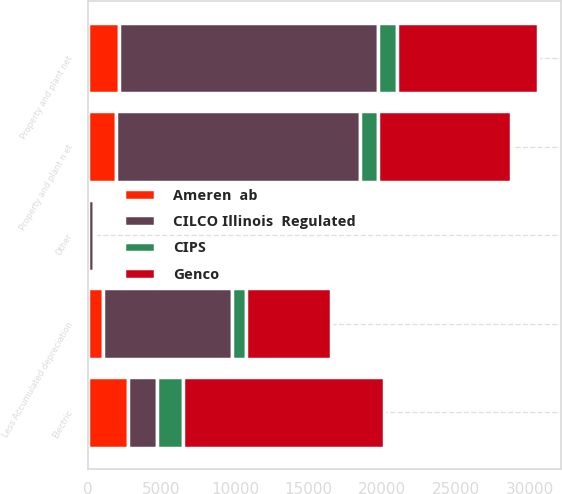<chart> <loc_0><loc_0><loc_500><loc_500><stacked_bar_chart><ecel><fcel>Electric<fcel>Other<fcel>Less Accumulated depreciation<fcel>Property and plant net<fcel>Property and plant n et<nl><fcel>CILCO Illinois  Regulated<fcel>1950<fcel>406<fcel>8787<fcel>17610<fcel>16567<nl><fcel>Genco<fcel>13627<fcel>85<fcel>5760<fcel>9585<fcel>8995<nl><fcel>CIPS<fcel>1796<fcel>6<fcel>923<fcel>1268<fcel>1212<nl><fcel>Ameren  ab<fcel>2730<fcel>6<fcel>1032<fcel>2135<fcel>1950<nl></chart> 